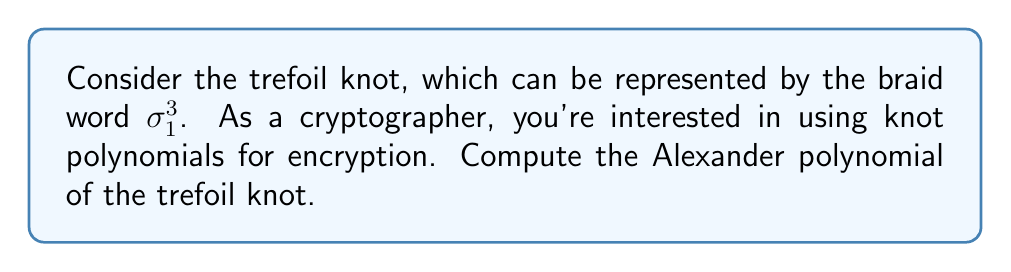Solve this math problem. Let's approach this step-by-step:

1) First, we need to create the Burau representation of the braid word $\sigma_1^3$. The Burau matrix for $\sigma_1$ is:

   $$B(\sigma_1) = \begin{pmatrix} -t & 1 \\ 0 & 1 \end{pmatrix}$$

2) We need to compute $B(\sigma_1)^3$:

   $$B(\sigma_1)^3 = \begin{pmatrix} -t & 1 \\ 0 & 1 \end{pmatrix}^3 = \begin{pmatrix} -t^3 & -t^2-t-1 \\ 0 & 1 \end{pmatrix}$$

3) Now, we need to compute the characteristic polynomial of this matrix minus the identity matrix:

   $$\det(B(\sigma_1)^3 - I) = \det\begin{pmatrix} -t^3-1 & -t^2-t-1 \\ 0 & 0 \end{pmatrix}$$

4) The determinant of this matrix is 0, so we need to divide by $(1-t)$ to get the Alexander polynomial:

   $$\Delta(t) = \frac{-t^3-1}{1-t} = t^2 + t + 1$$

5) Finally, we typically normalize the Alexander polynomial so that the lowest degree term is positive and the polynomial is symmetric. In this case, our polynomial is already in this form.
Answer: $\Delta(t) = t^2 + t + 1$ 